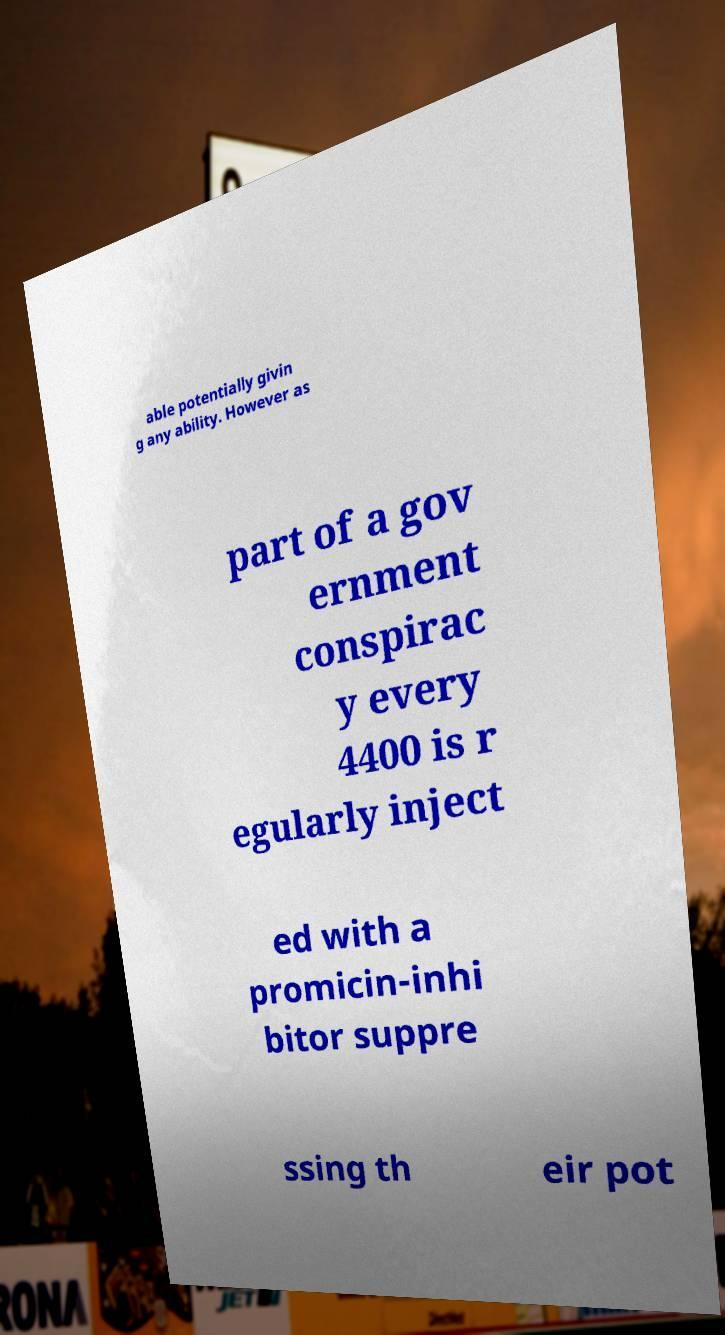Could you assist in decoding the text presented in this image and type it out clearly? able potentially givin g any ability. However as part of a gov ernment conspirac y every 4400 is r egularly inject ed with a promicin-inhi bitor suppre ssing th eir pot 